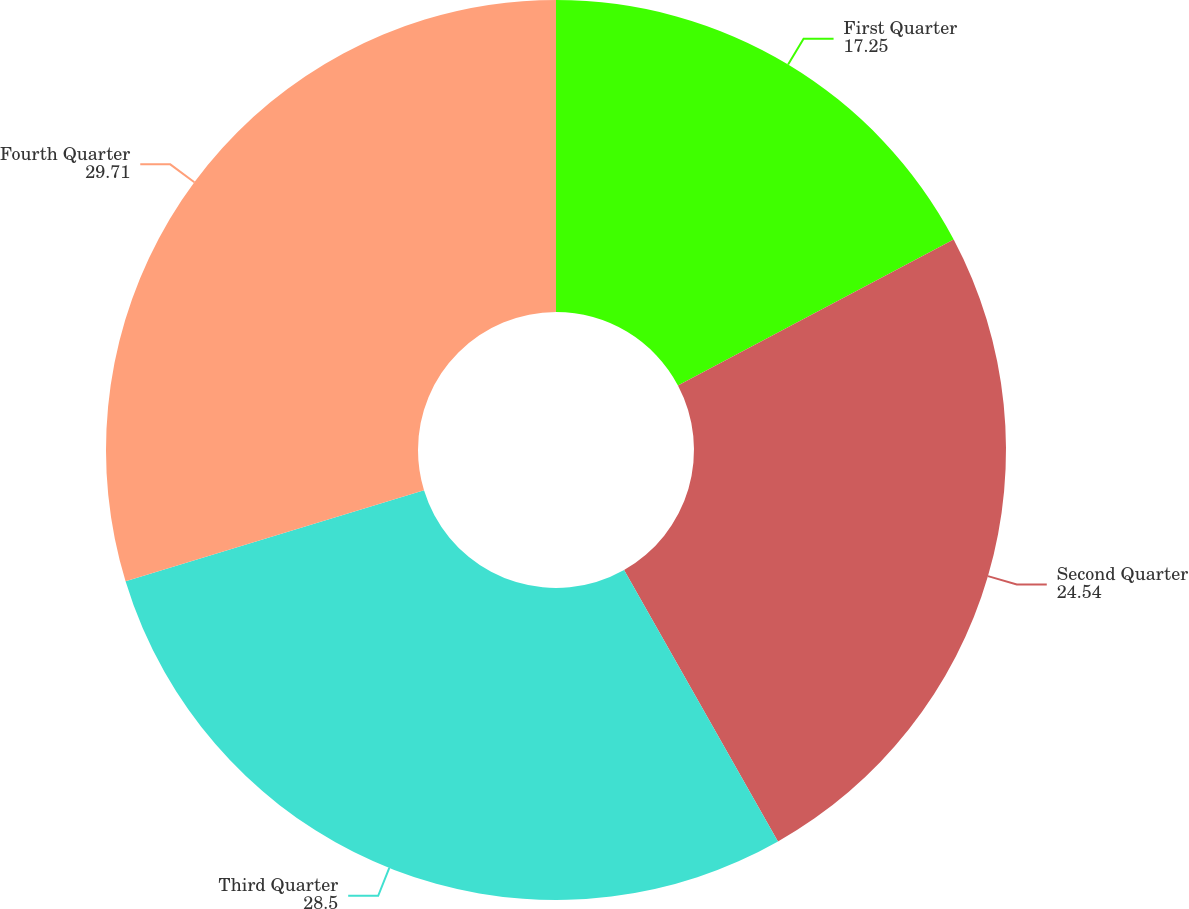Convert chart. <chart><loc_0><loc_0><loc_500><loc_500><pie_chart><fcel>First Quarter<fcel>Second Quarter<fcel>Third Quarter<fcel>Fourth Quarter<nl><fcel>17.25%<fcel>24.54%<fcel>28.5%<fcel>29.71%<nl></chart> 